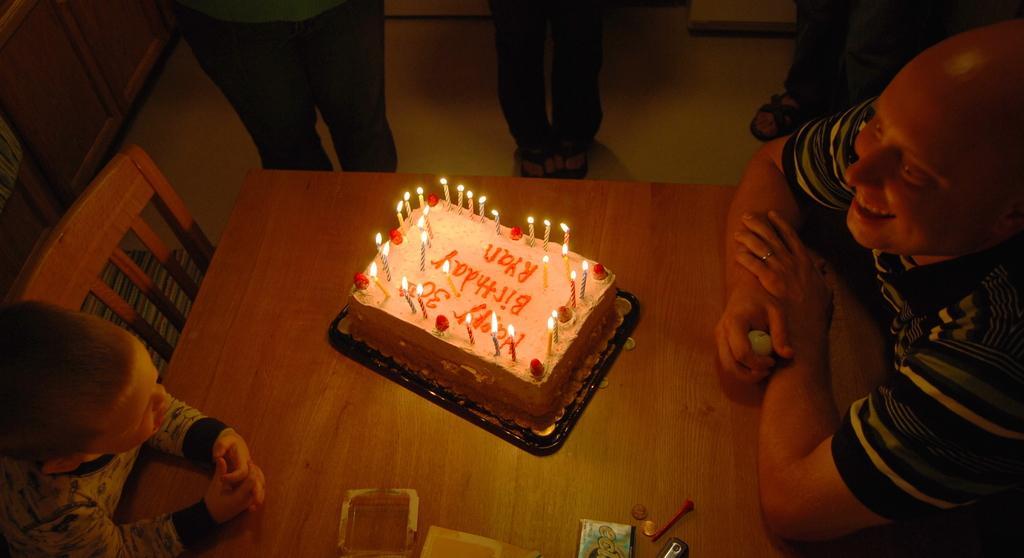Please provide a concise description of this image. In this image we can see there are a few people sitting on the chair and a few people standing on the floor. And there is a table, on the table there is a cake with tray and candles. And there are few objects on it. At the side, it looks like a cupboard. 